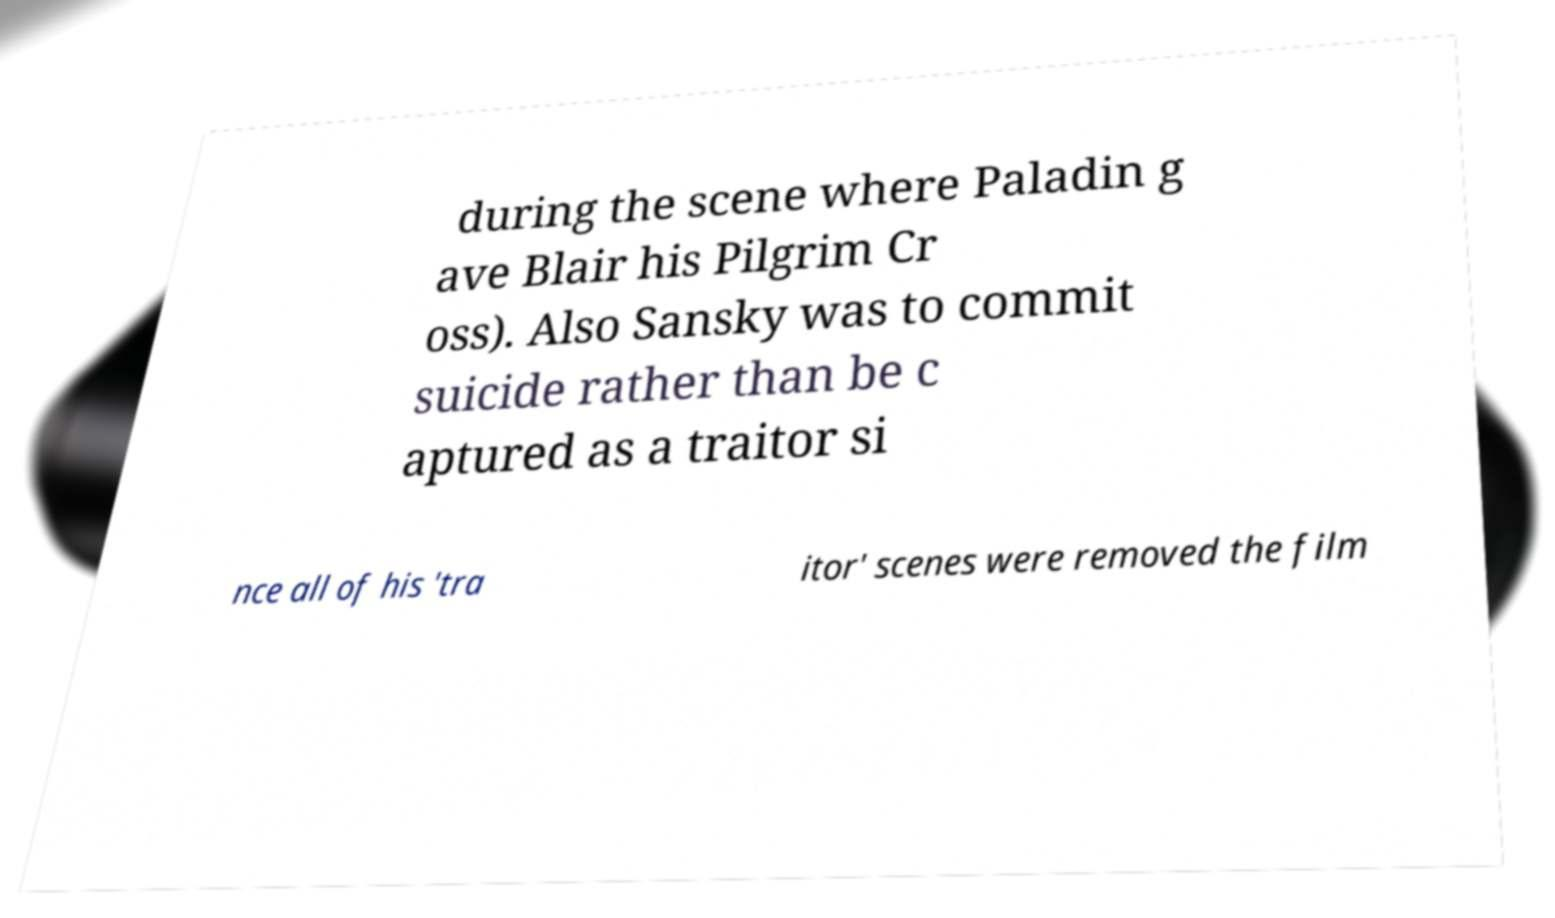Can you accurately transcribe the text from the provided image for me? during the scene where Paladin g ave Blair his Pilgrim Cr oss). Also Sansky was to commit suicide rather than be c aptured as a traitor si nce all of his 'tra itor' scenes were removed the film 